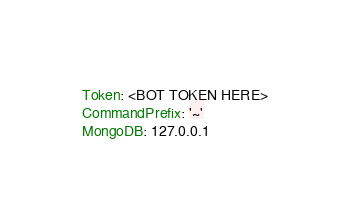<code> <loc_0><loc_0><loc_500><loc_500><_YAML_>Token: <BOT TOKEN HERE>
CommandPrefix: '~'
MongoDB: 127.0.0.1
</code> 